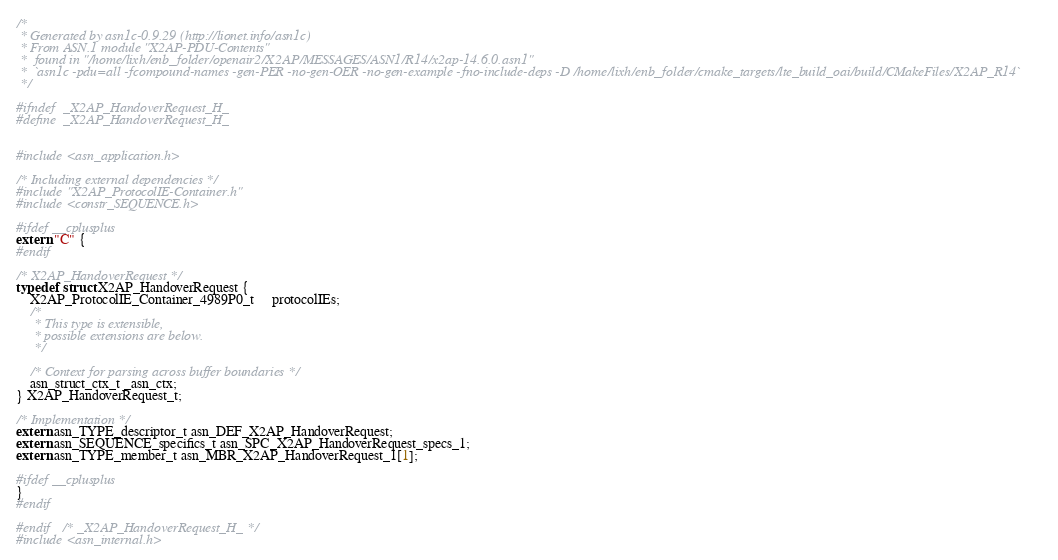Convert code to text. <code><loc_0><loc_0><loc_500><loc_500><_C_>/*
 * Generated by asn1c-0.9.29 (http://lionet.info/asn1c)
 * From ASN.1 module "X2AP-PDU-Contents"
 * 	found in "/home/lixh/enb_folder/openair2/X2AP/MESSAGES/ASN1/R14/x2ap-14.6.0.asn1"
 * 	`asn1c -pdu=all -fcompound-names -gen-PER -no-gen-OER -no-gen-example -fno-include-deps -D /home/lixh/enb_folder/cmake_targets/lte_build_oai/build/CMakeFiles/X2AP_R14`
 */

#ifndef	_X2AP_HandoverRequest_H_
#define	_X2AP_HandoverRequest_H_


#include <asn_application.h>

/* Including external dependencies */
#include "X2AP_ProtocolIE-Container.h"
#include <constr_SEQUENCE.h>

#ifdef __cplusplus
extern "C" {
#endif

/* X2AP_HandoverRequest */
typedef struct X2AP_HandoverRequest {
	X2AP_ProtocolIE_Container_4989P0_t	 protocolIEs;
	/*
	 * This type is extensible,
	 * possible extensions are below.
	 */
	
	/* Context for parsing across buffer boundaries */
	asn_struct_ctx_t _asn_ctx;
} X2AP_HandoverRequest_t;

/* Implementation */
extern asn_TYPE_descriptor_t asn_DEF_X2AP_HandoverRequest;
extern asn_SEQUENCE_specifics_t asn_SPC_X2AP_HandoverRequest_specs_1;
extern asn_TYPE_member_t asn_MBR_X2AP_HandoverRequest_1[1];

#ifdef __cplusplus
}
#endif

#endif	/* _X2AP_HandoverRequest_H_ */
#include <asn_internal.h>
</code> 